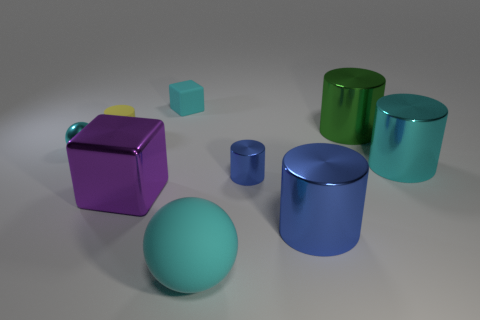Is there a pattern in the arrangement of these objects? The objects seem to be arranged randomly with no apparent pattern. They are spaced out with varying distances between them, and their placement does not follow a specific order or symmetry. 